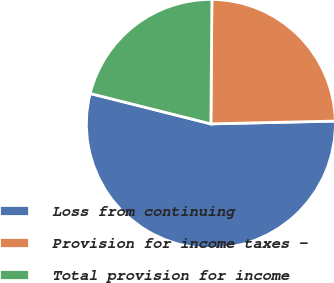Convert chart. <chart><loc_0><loc_0><loc_500><loc_500><pie_chart><fcel>Loss from continuing<fcel>Provision for income taxes -<fcel>Total provision for income<nl><fcel>54.28%<fcel>24.51%<fcel>21.21%<nl></chart> 